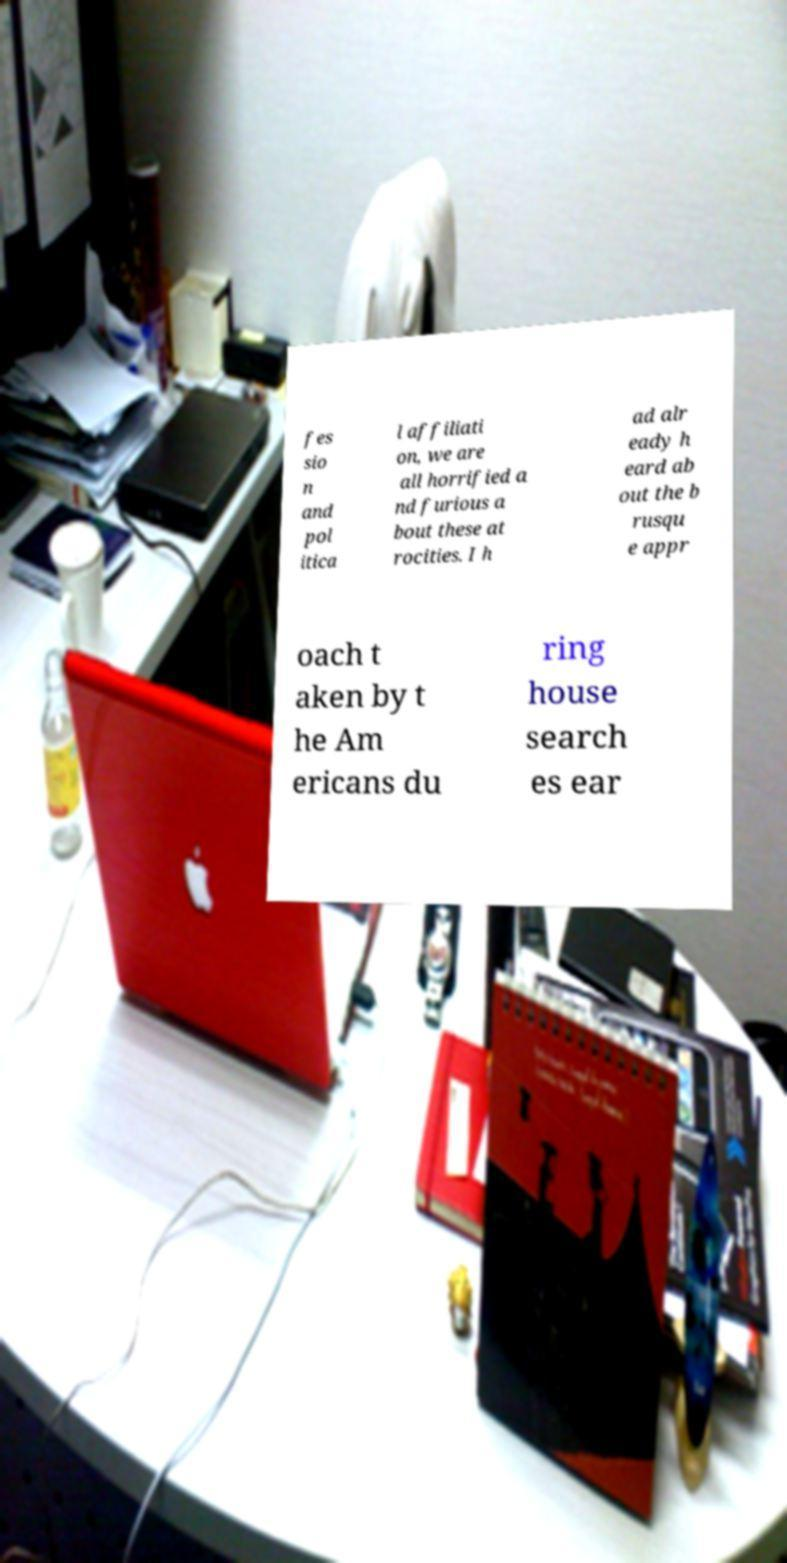Can you accurately transcribe the text from the provided image for me? fes sio n and pol itica l affiliati on, we are all horrified a nd furious a bout these at rocities. I h ad alr eady h eard ab out the b rusqu e appr oach t aken by t he Am ericans du ring house search es ear 